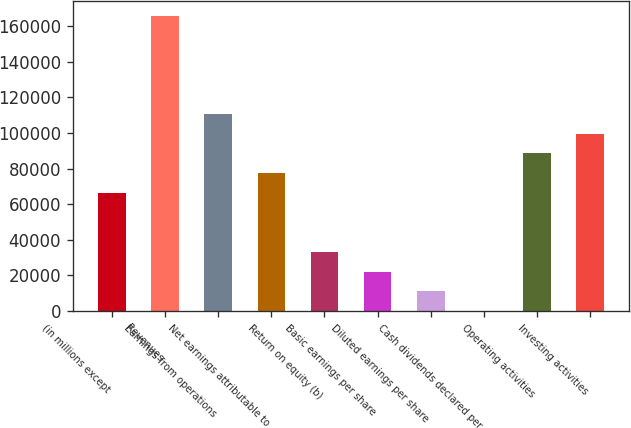Convert chart. <chart><loc_0><loc_0><loc_500><loc_500><bar_chart><fcel>(in millions except<fcel>Revenues<fcel>Earnings from operations<fcel>Net earnings attributable to<fcel>Return on equity (b)<fcel>Basic earnings per share<fcel>Diluted earnings per share<fcel>Cash dividends declared per<fcel>Operating activities<fcel>Investing activities<nl><fcel>66371.1<fcel>165927<fcel>110618<fcel>77432.8<fcel>33186<fcel>22124.2<fcel>11062.5<fcel>0.8<fcel>88494.6<fcel>99556.3<nl></chart> 